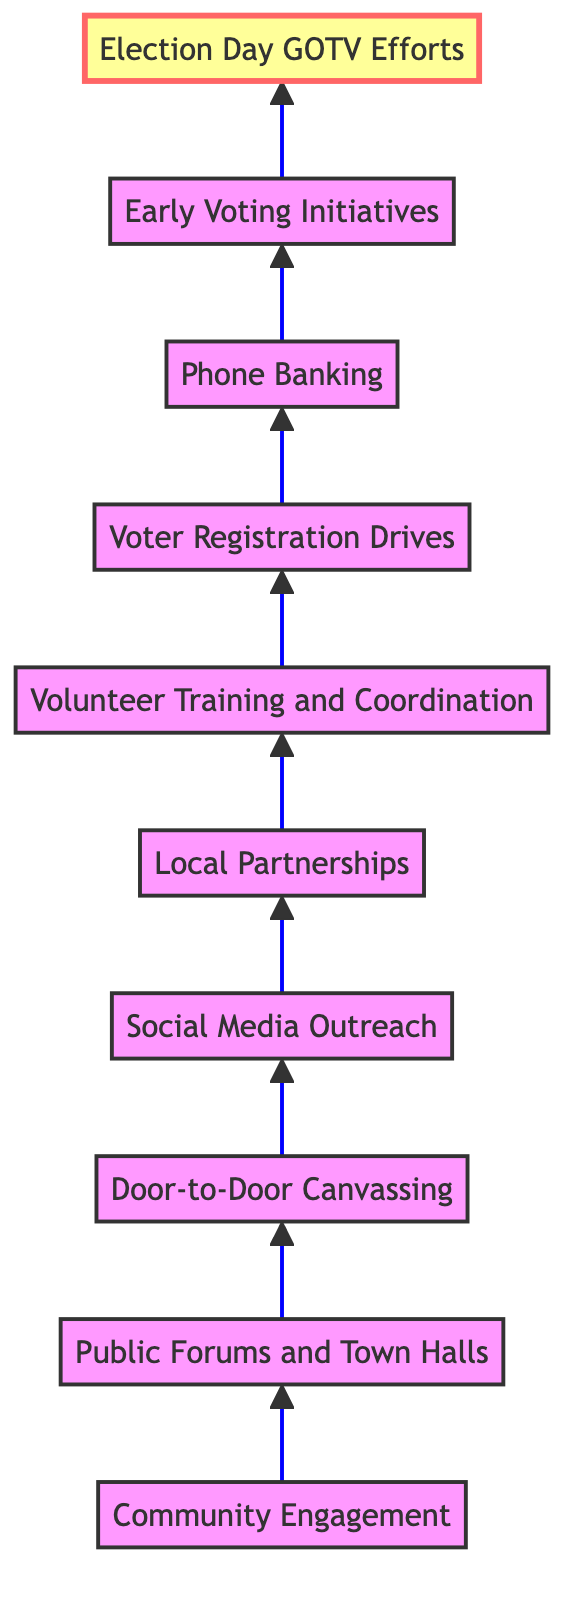What is the top element in the diagram? The top element can be identified as the last item in the flow, which is connected to all the preceding elements and represents the final goal of the grassroots campaign strategies. In this case, it is "Election Day GOTV Efforts."
Answer: Election Day GOTV Efforts How many total elements are in the diagram? To find the total number of elements, we count each distinct strategy mentioned from the flowchart. There are ten elements in total, ranging from community engagement to election day efforts.
Answer: 10 What element comes directly before "Social Media Outreach"? Tracing back the flow of the diagram, "Social Media Outreach" is preceded directly by "Door-to-Door Canvassing," as each element points to the next in sequence.
Answer: Door-to-Door Canvassing Which element emphasizes voter engagement strategies? The element that focuses on voter engagement strategies through training and coordination is "Volunteer Training and Coordination," as it specifically mentions educating volunteers on these tactics.
Answer: Volunteer Training and Coordination What is the relationship between "Voter Registration Drives" and "Early Voting Initiatives"? In the flowchart, "Voter Registration Drives" leads to "Early Voting Initiatives," indicating that efforts to register voters support initiatives to encourage early voting, thus showing a sequential relationship between the two elements.
Answer: Sequential relationship How many elements are linked to "Community Engagement"? By reviewing the connections in the diagram, we see "Community Engagement" directly points to "Public Forums and Town Halls," indicating there is one direct link to the next level and further down the flow, multiple connections lead to "Election Day GOTV Efforts."
Answer: 1 What action follows "Phone Banking" in the campaign strategy? Following "Phone Banking," the next action in the grassroots campaign is "Early Voting Initiatives," which is reached by following the arrows upward in the flow chart.
Answer: Early Voting Initiatives Which element represents the final push for voter turnout? The final push for voter turnout is represented by "Election Day GOTV Efforts," which encompasses various actions aimed at ensuring maximum participation on Election Day itself.
Answer: Election Day GOTV Efforts What does "Local Partnerships" help to increase? "Local Partnerships" specifically helps to increase campaign visibility and support, according to the details provided in the flowchart.
Answer: Campaign visibility and support 